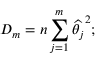Convert formula to latex. <formula><loc_0><loc_0><loc_500><loc_500>D _ { m } = n \sum _ { j = 1 } ^ { m } \widehat { \theta _ { j } } ^ { 2 } ;</formula> 